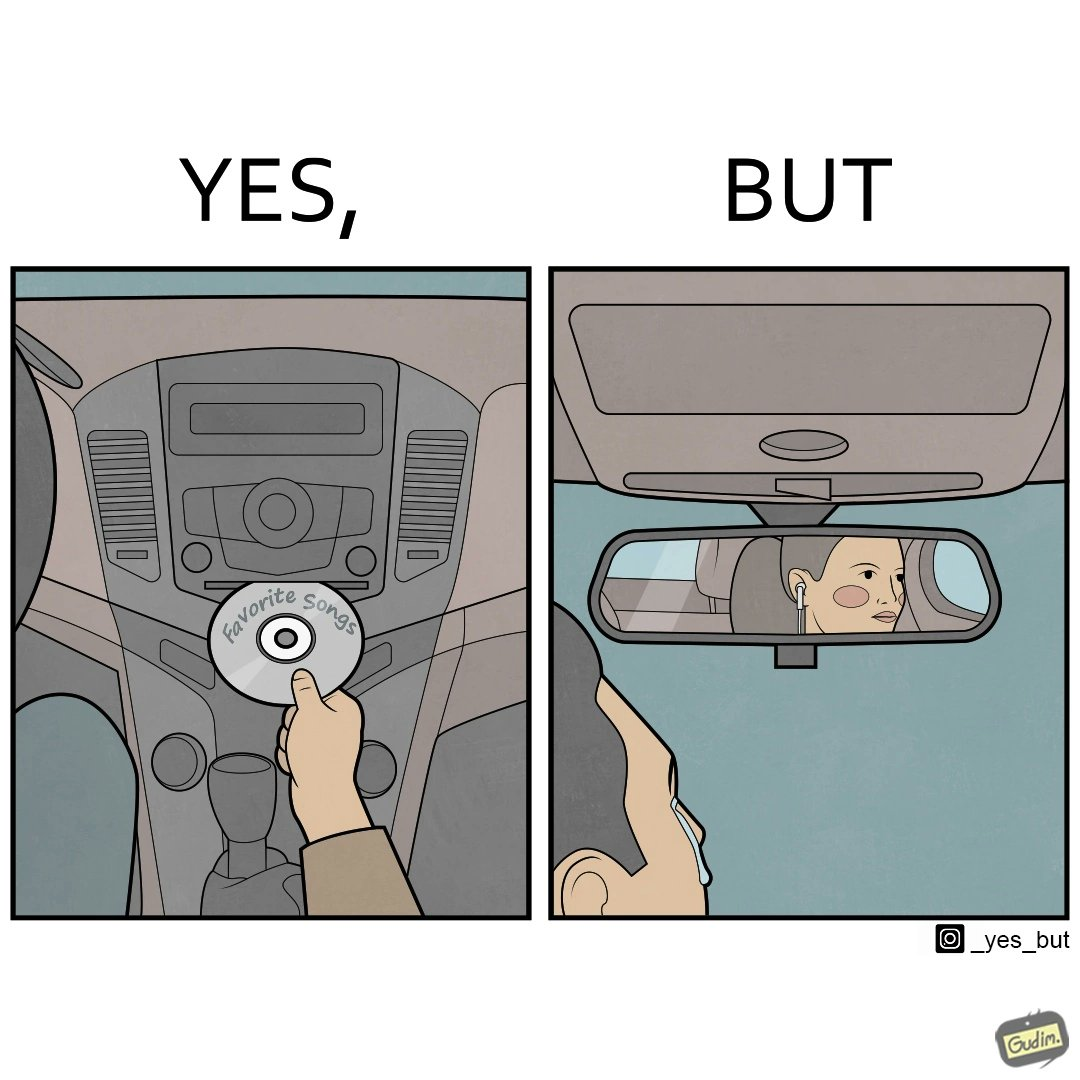What is shown in the left half versus the right half of this image? In the left part of the image: a person in the driving seat is inserting a CD with "Favorite Songs" written on it into the CD player of a car dashboard. In the right part of the image: driver of the car is sad on seeing the person (on the rear view mirror) sitting in the back seat of the car wearing earphones. 